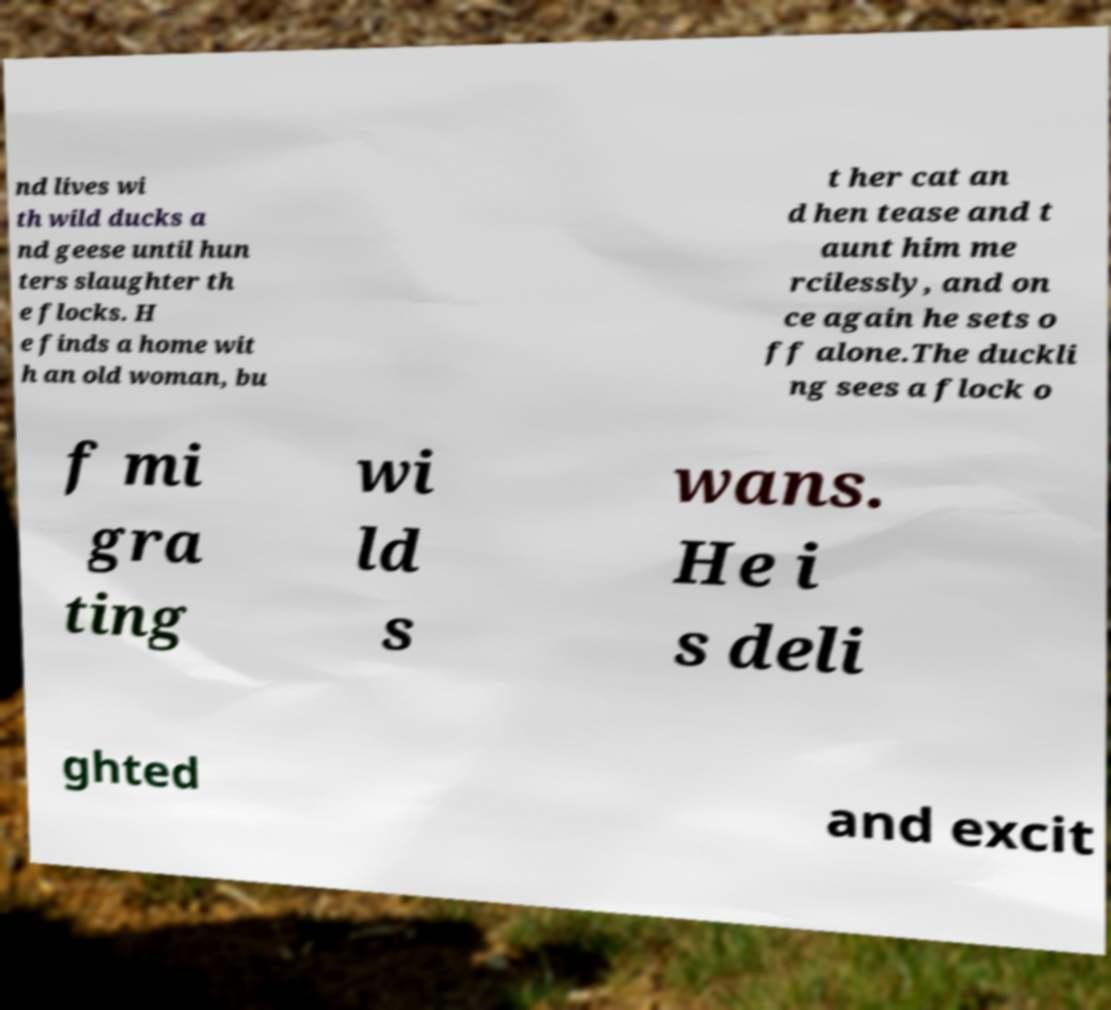What messages or text are displayed in this image? I need them in a readable, typed format. nd lives wi th wild ducks a nd geese until hun ters slaughter th e flocks. H e finds a home wit h an old woman, bu t her cat an d hen tease and t aunt him me rcilessly, and on ce again he sets o ff alone.The duckli ng sees a flock o f mi gra ting wi ld s wans. He i s deli ghted and excit 